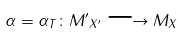<formula> <loc_0><loc_0><loc_500><loc_500>\alpha = \alpha _ { T } \colon { M ^ { \prime } } _ { X ^ { \prime } } \longrightarrow M _ { X }</formula> 